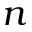<formula> <loc_0><loc_0><loc_500><loc_500>n</formula> 